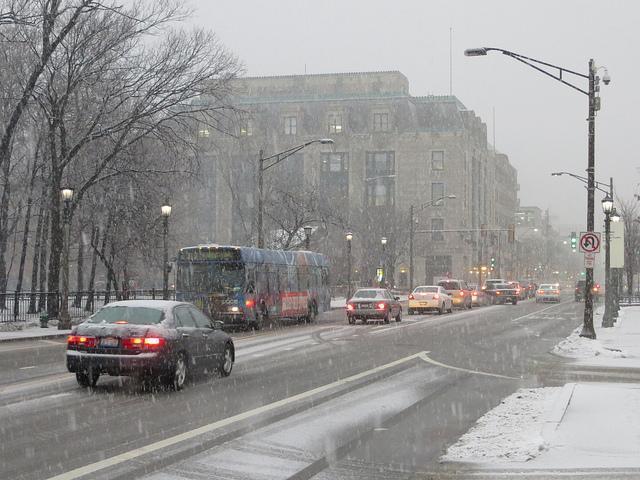How many green lights are there?
Give a very brief answer. 2. 